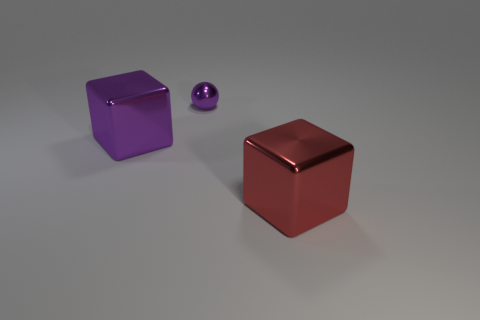What is the material of the big object right of the purple object on the right side of the purple thing in front of the purple metallic sphere?
Your response must be concise. Metal. Is the number of large purple metallic cubes right of the purple metal cube greater than the number of big purple metal things that are to the left of the tiny object?
Keep it short and to the point. No. How many cubes are either red things or tiny matte things?
Provide a short and direct response. 1. There is a big metallic block behind the large shiny thing that is right of the purple ball; what number of big shiny objects are to the right of it?
Offer a terse response. 1. What is the material of the block that is the same color as the tiny thing?
Provide a short and direct response. Metal. Is the number of yellow cubes greater than the number of blocks?
Provide a short and direct response. No. Do the red block and the sphere have the same size?
Provide a succinct answer. No. What number of objects are either purple metallic objects or large red metallic things?
Provide a short and direct response. 3. What is the shape of the tiny purple object that is behind the big thing behind the big red thing to the right of the purple metallic sphere?
Ensure brevity in your answer.  Sphere. Is the large thing that is to the left of the big red metal cube made of the same material as the tiny purple sphere left of the big red metal object?
Provide a short and direct response. Yes. 